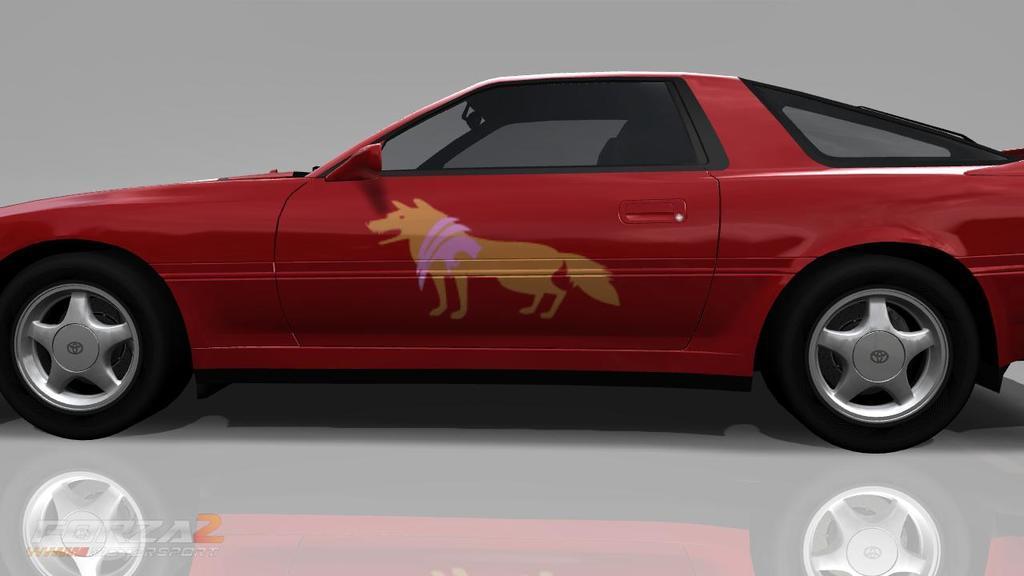Can you describe this image briefly? In this image I can see a car which is red and black in color on the white colored surface and I can see the grey colored background. 